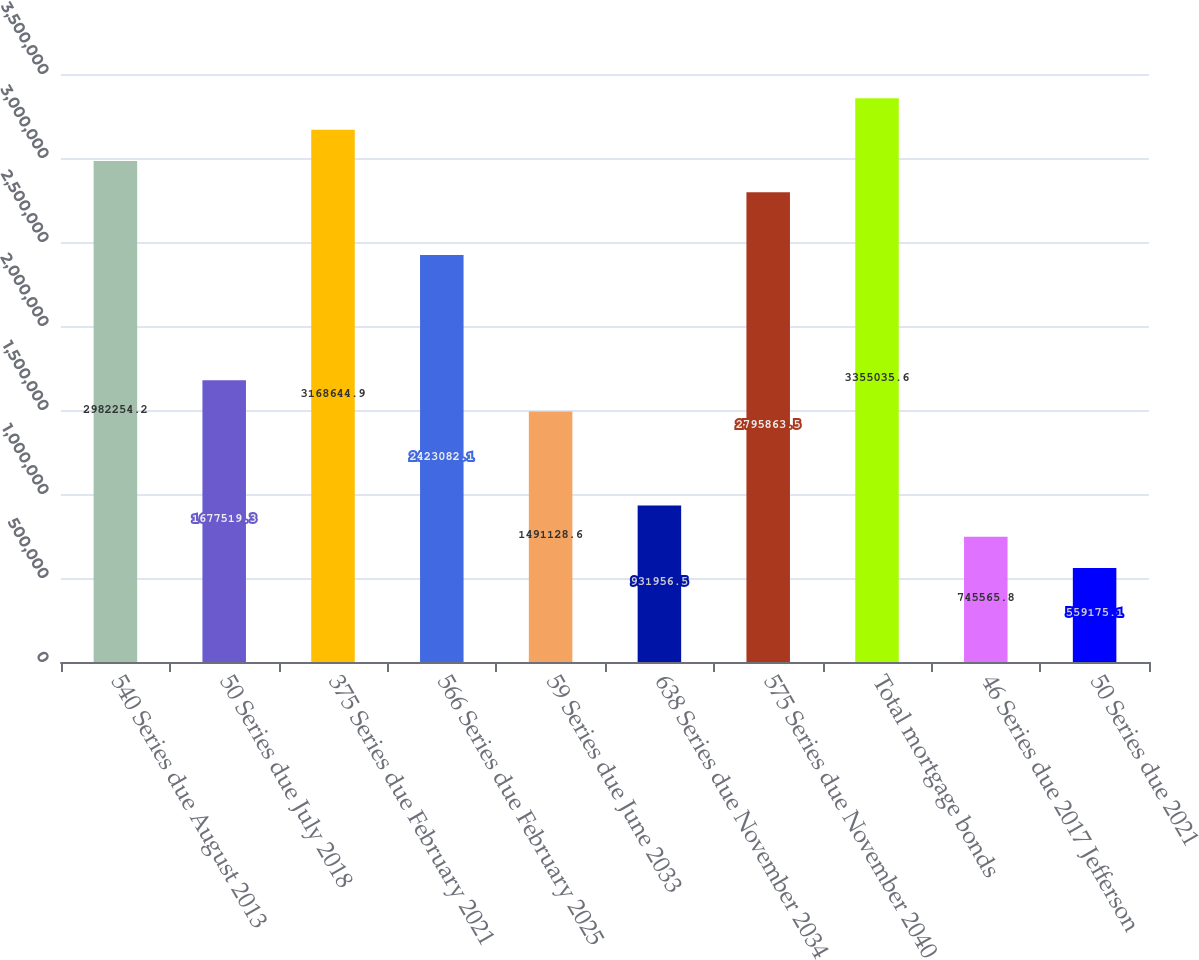Convert chart to OTSL. <chart><loc_0><loc_0><loc_500><loc_500><bar_chart><fcel>540 Series due August 2013<fcel>50 Series due July 2018<fcel>375 Series due February 2021<fcel>566 Series due February 2025<fcel>59 Series due June 2033<fcel>638 Series due November 2034<fcel>575 Series due November 2040<fcel>Total mortgage bonds<fcel>46 Series due 2017 Jefferson<fcel>50 Series due 2021<nl><fcel>2.98225e+06<fcel>1.67752e+06<fcel>3.16864e+06<fcel>2.42308e+06<fcel>1.49113e+06<fcel>931956<fcel>2.79586e+06<fcel>3.35504e+06<fcel>745566<fcel>559175<nl></chart> 